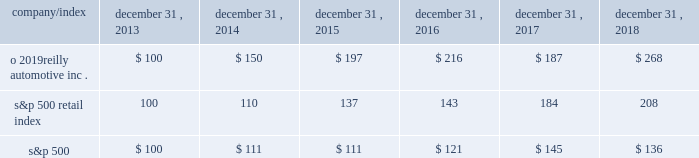Stock performance graph : the graph below shows the cumulative total shareholder return assuming the investment of $ 100 , on december 31 , 2013 , and the reinvestment of dividends thereafter , if any , in the company 2019s common stock versus the standard and poor 2019s s&p 500 retail index ( 201cs&p 500 retail index 201d ) and the standard and poor 2019s s&p 500 index ( 201cs&p 500 201d ) . .

What was the five year change in value of the o 2019reilly automotive inc . stock? 
Computations: (268 - 100)
Answer: 168.0. Stock performance graph : the graph below shows the cumulative total shareholder return assuming the investment of $ 100 , on december 31 , 2013 , and the reinvestment of dividends thereafter , if any , in the company 2019s common stock versus the standard and poor 2019s s&p 500 retail index ( 201cs&p 500 retail index 201d ) and the standard and poor 2019s s&p 500 index ( 201cs&p 500 201d ) . .

What is the roi of an investment in s&p500 from 2013 to 2017? 
Computations: ((145 - 100) / 100)
Answer: 0.45. 